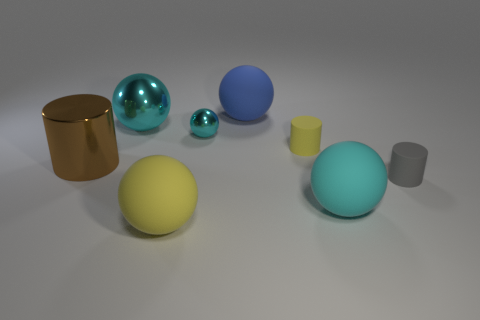There is a object that is both right of the tiny yellow thing and on the left side of the gray rubber object; what size is it?
Provide a succinct answer. Large. There is a small cyan shiny thing; is it the same shape as the cyan thing to the left of the big yellow thing?
Your answer should be compact. Yes. What is the size of the other rubber thing that is the same shape as the tiny yellow object?
Provide a short and direct response. Small. Do the small metallic thing and the large object to the right of the big blue matte thing have the same color?
Keep it short and to the point. Yes. How many other objects are the same size as the cyan matte thing?
Ensure brevity in your answer.  4. There is a metal thing in front of the tiny object that is on the left side of the large rubber thing behind the small yellow cylinder; what shape is it?
Your answer should be very brief. Cylinder. There is a brown object; is its size the same as the matte thing behind the big metallic sphere?
Your response must be concise. Yes. There is a large object that is on the right side of the large yellow sphere and in front of the tiny gray cylinder; what is its color?
Your answer should be compact. Cyan. How many other objects are the same shape as the tiny yellow thing?
Keep it short and to the point. 2. There is a metal ball to the right of the big yellow ball; does it have the same color as the large metallic ball behind the tiny gray matte thing?
Offer a terse response. Yes. 